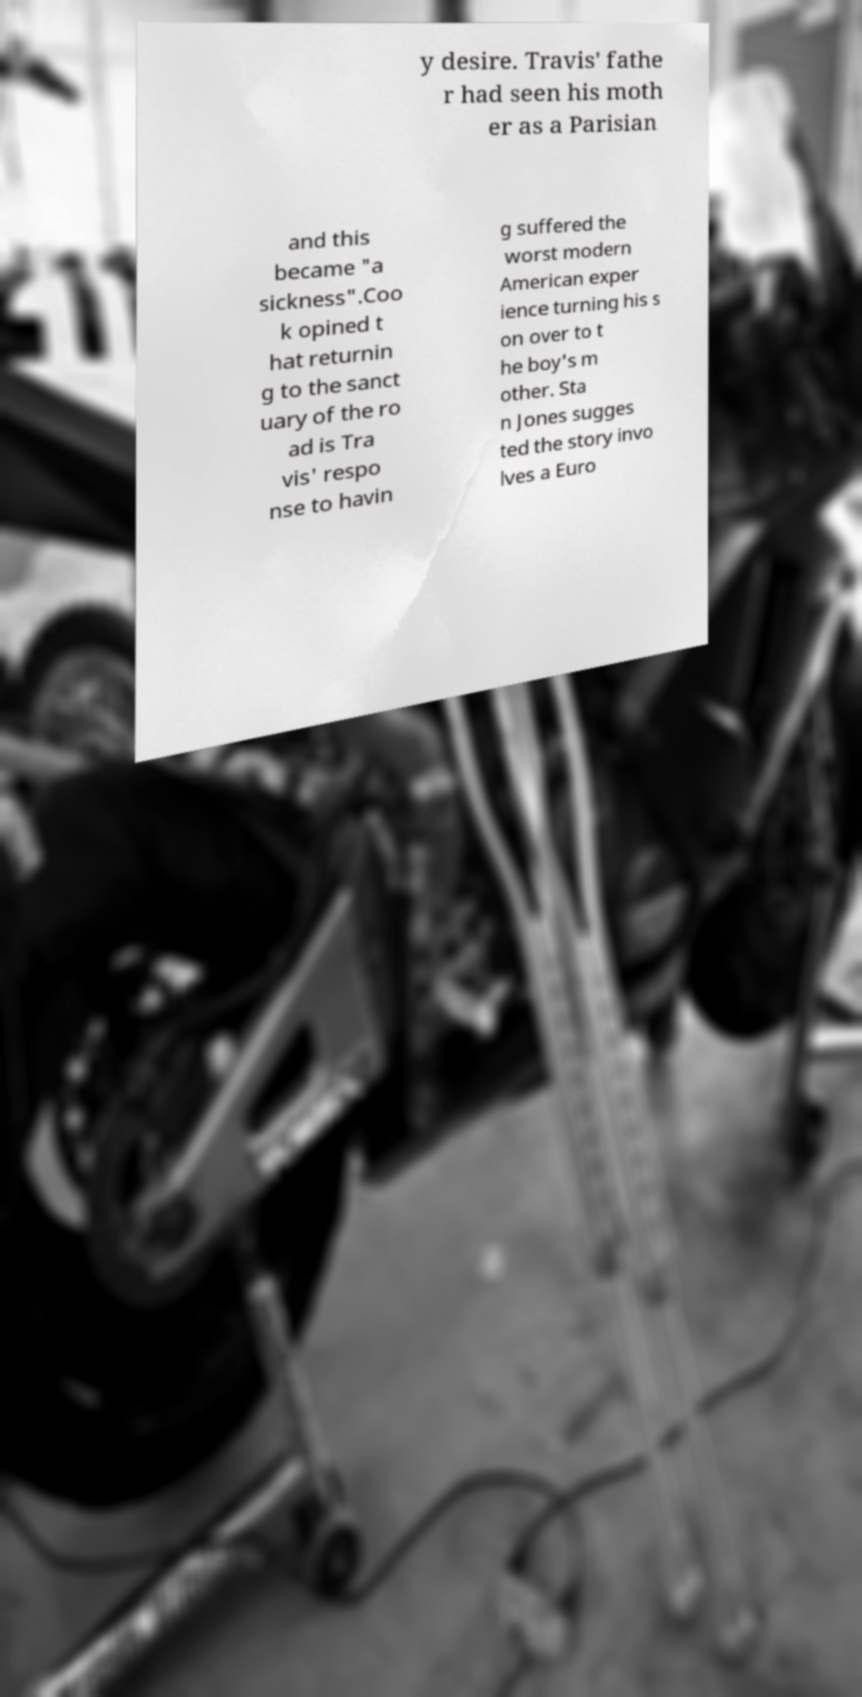For documentation purposes, I need the text within this image transcribed. Could you provide that? y desire. Travis' fathe r had seen his moth er as a Parisian and this became "a sickness".Coo k opined t hat returnin g to the sanct uary of the ro ad is Tra vis' respo nse to havin g suffered the worst modern American exper ience turning his s on over to t he boy's m other. Sta n Jones sugges ted the story invo lves a Euro 